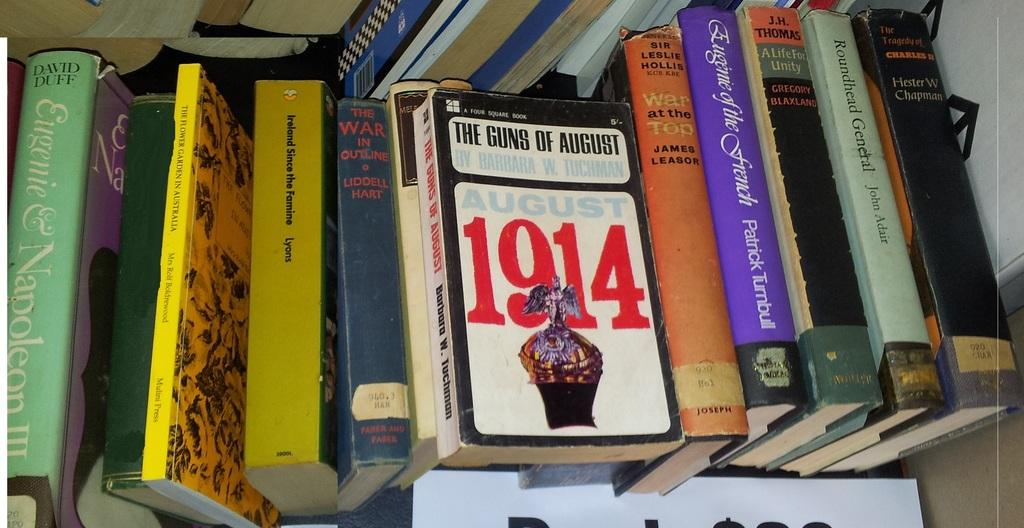<image>
Provide a brief description of the given image. many books one of which says 1914 on it 